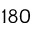<formula> <loc_0><loc_0><loc_500><loc_500>1 8 0</formula> 